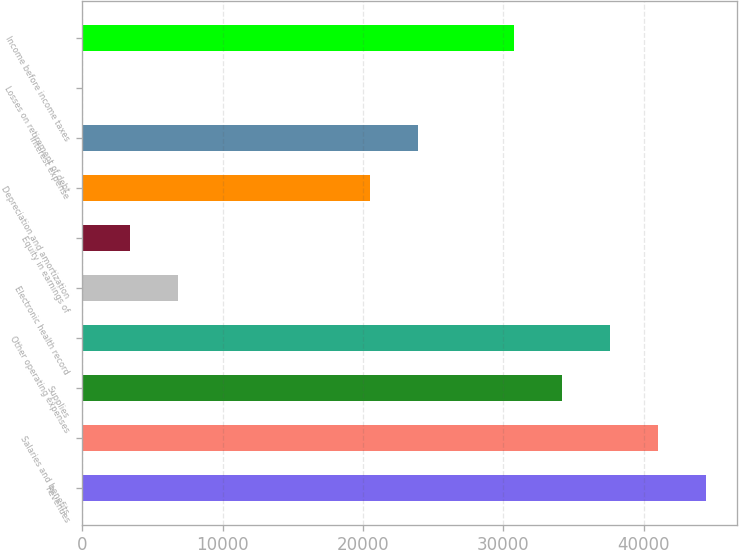<chart> <loc_0><loc_0><loc_500><loc_500><bar_chart><fcel>Revenues<fcel>Salaries and benefits<fcel>Supplies<fcel>Other operating expenses<fcel>Electronic health record<fcel>Equity in earnings of<fcel>Depreciation and amortization<fcel>Interest expense<fcel>Losses on retirement of debt<fcel>Income before income taxes<nl><fcel>44431.5<fcel>41015<fcel>34182<fcel>37598.5<fcel>6850<fcel>3433.5<fcel>20516<fcel>23932.5<fcel>17<fcel>30765.5<nl></chart> 